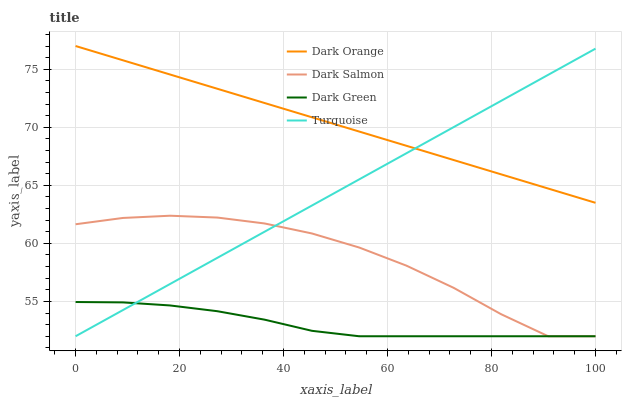Does Dark Green have the minimum area under the curve?
Answer yes or no. Yes. Does Dark Orange have the maximum area under the curve?
Answer yes or no. Yes. Does Turquoise have the minimum area under the curve?
Answer yes or no. No. Does Turquoise have the maximum area under the curve?
Answer yes or no. No. Is Turquoise the smoothest?
Answer yes or no. Yes. Is Dark Salmon the roughest?
Answer yes or no. Yes. Is Dark Salmon the smoothest?
Answer yes or no. No. Is Turquoise the roughest?
Answer yes or no. No. Does Dark Orange have the highest value?
Answer yes or no. Yes. Does Turquoise have the highest value?
Answer yes or no. No. Is Dark Green less than Dark Orange?
Answer yes or no. Yes. Is Dark Orange greater than Dark Salmon?
Answer yes or no. Yes. Does Dark Salmon intersect Turquoise?
Answer yes or no. Yes. Is Dark Salmon less than Turquoise?
Answer yes or no. No. Is Dark Salmon greater than Turquoise?
Answer yes or no. No. Does Dark Green intersect Dark Orange?
Answer yes or no. No. 